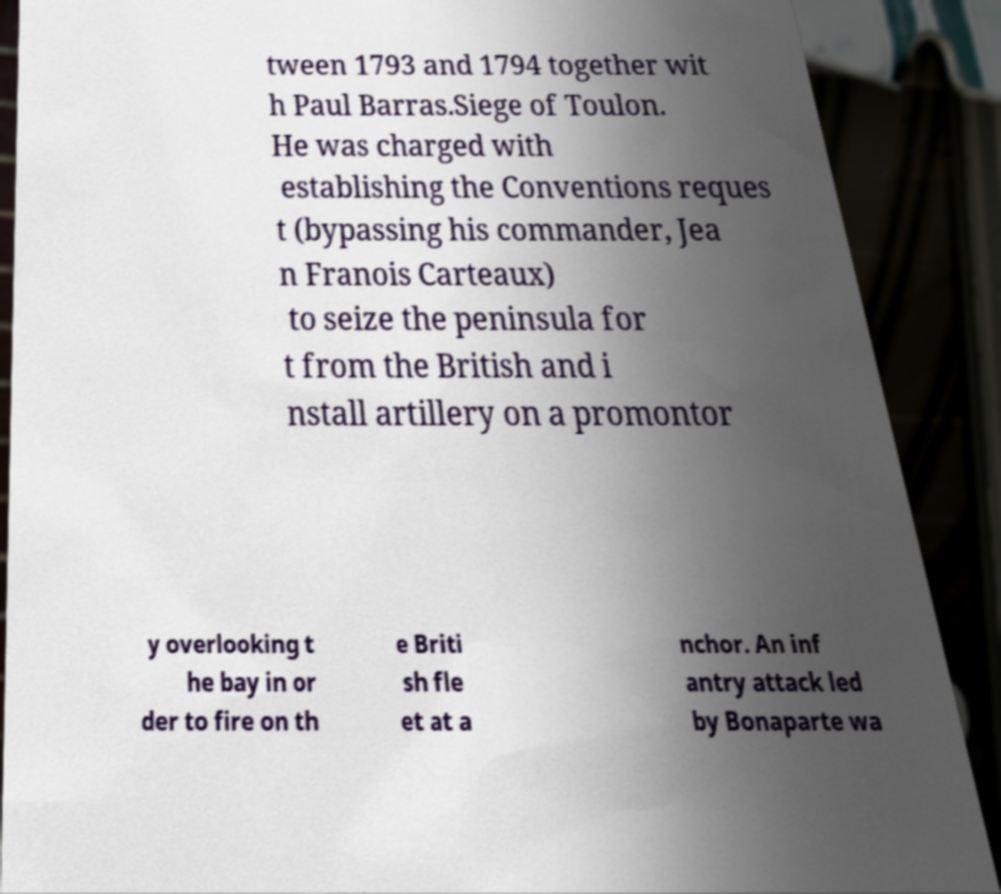I need the written content from this picture converted into text. Can you do that? tween 1793 and 1794 together wit h Paul Barras.Siege of Toulon. He was charged with establishing the Conventions reques t (bypassing his commander, Jea n Franois Carteaux) to seize the peninsula for t from the British and i nstall artillery on a promontor y overlooking t he bay in or der to fire on th e Briti sh fle et at a nchor. An inf antry attack led by Bonaparte wa 